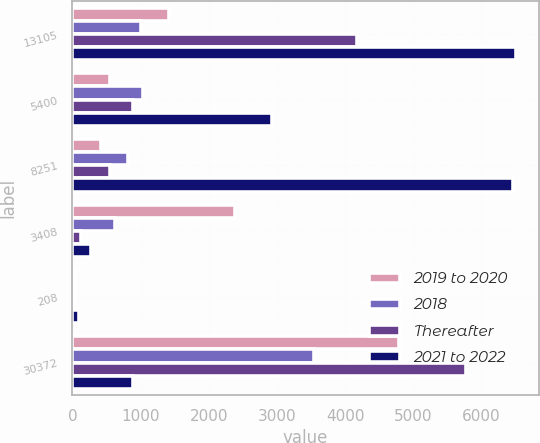Convert chart to OTSL. <chart><loc_0><loc_0><loc_500><loc_500><stacked_bar_chart><ecel><fcel>13105<fcel>5400<fcel>8251<fcel>3408<fcel>208<fcel>30372<nl><fcel>2019 to 2020<fcel>1414<fcel>546<fcel>420<fcel>2383<fcel>34<fcel>4797<nl><fcel>2018<fcel>1006<fcel>1042<fcel>819<fcel>628<fcel>44<fcel>3539<nl><fcel>Thereafter<fcel>4171<fcel>885<fcel>551<fcel>127<fcel>35<fcel>5769<nl><fcel>2021 to 2022<fcel>6514<fcel>2927<fcel>6461<fcel>270<fcel>95<fcel>885<nl></chart> 